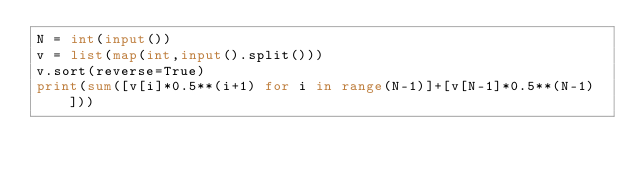Convert code to text. <code><loc_0><loc_0><loc_500><loc_500><_Python_>N = int(input())
v = list(map(int,input().split()))
v.sort(reverse=True)
print(sum([v[i]*0.5**(i+1) for i in range(N-1)]+[v[N-1]*0.5**(N-1)]))</code> 